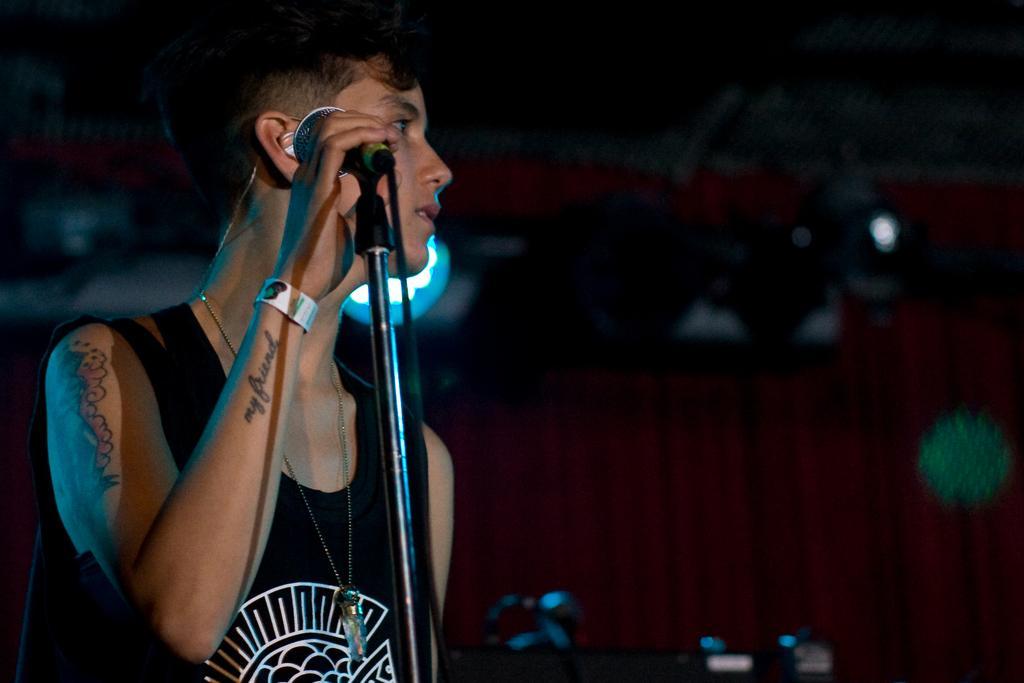Can you describe this image briefly? In this image I can see a man is standing by holding the microphone. He wore black color top, there are tattoos on his body. 